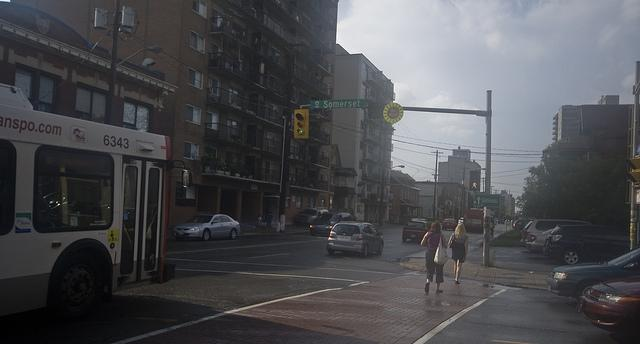Why is the street shiny?

Choices:
A) just rained
B) newly topped
C) bright sunshine
D) just painted just rained 